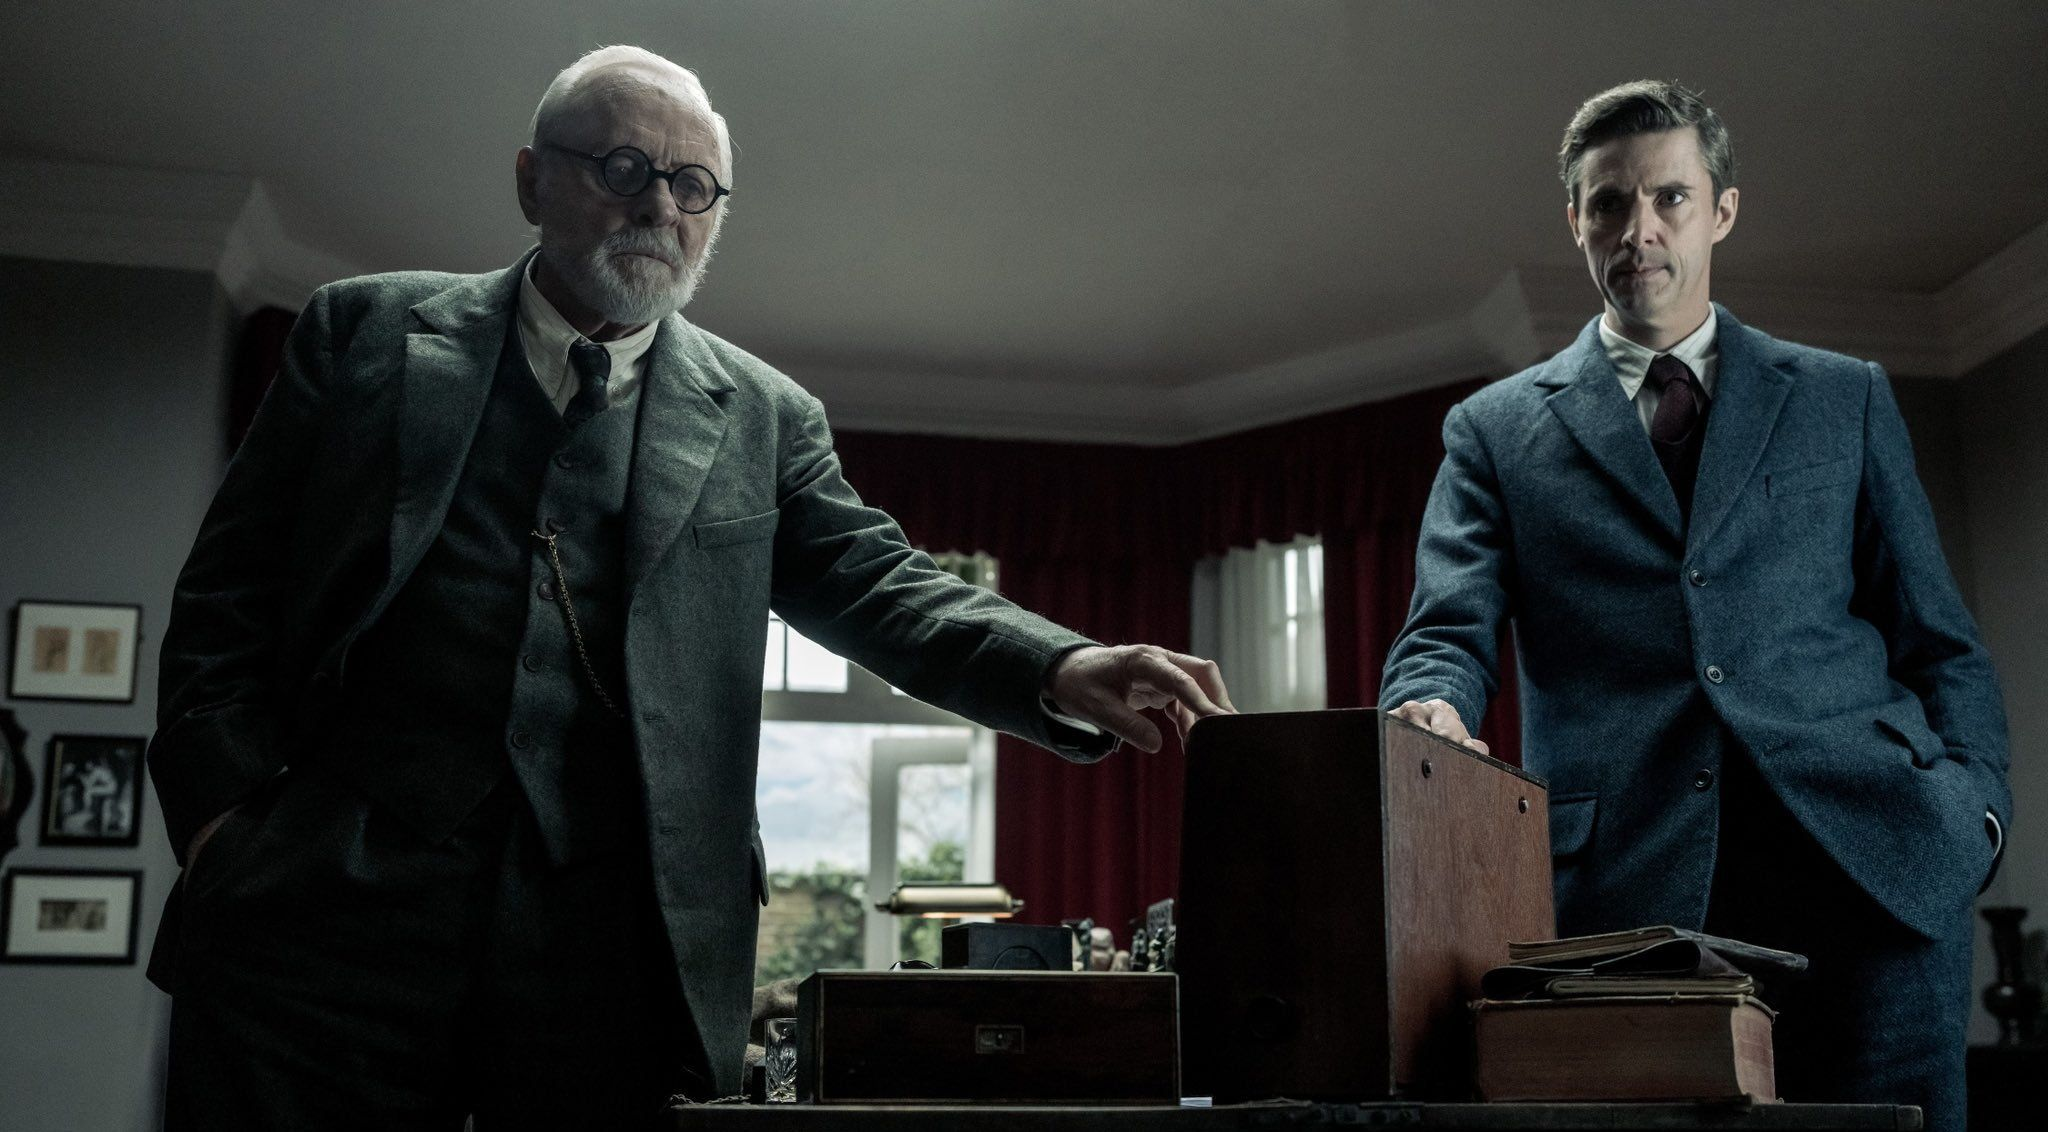What's happening in the scene? In this image, we observe a dramatic scene from a film. On the left side, a distinguished elderly man dressed in a gray suit and glasses is seen with his hand resting on a wooden desk, exuding an air of authority. On the right stands a younger man in a blue suit and tie, with a stern expression as he looks back at the elderly man. The red curtains and framed pictures on the wall create a tense atmosphere, suggesting a serious conversation or confrontation between the two. 